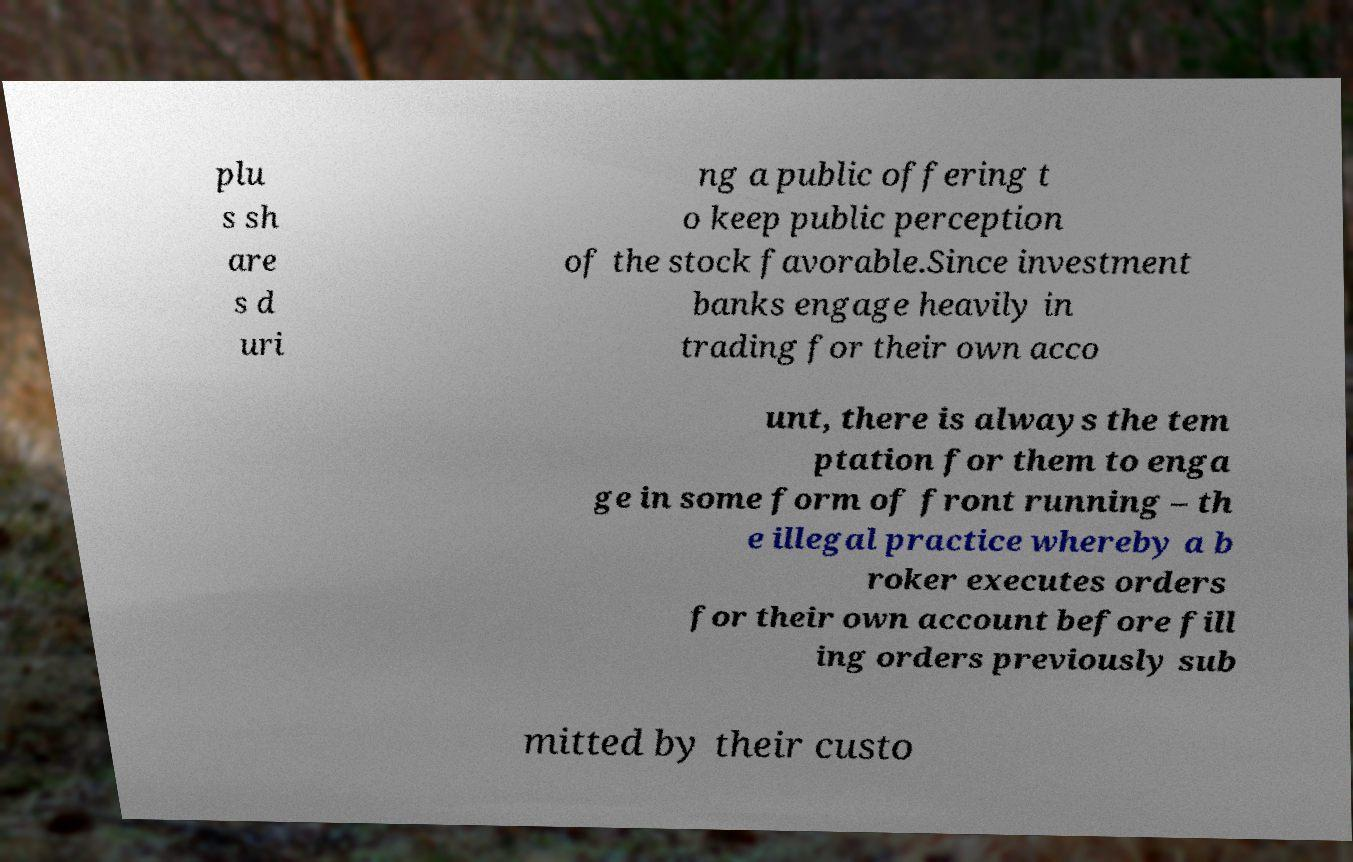There's text embedded in this image that I need extracted. Can you transcribe it verbatim? plu s sh are s d uri ng a public offering t o keep public perception of the stock favorable.Since investment banks engage heavily in trading for their own acco unt, there is always the tem ptation for them to enga ge in some form of front running – th e illegal practice whereby a b roker executes orders for their own account before fill ing orders previously sub mitted by their custo 